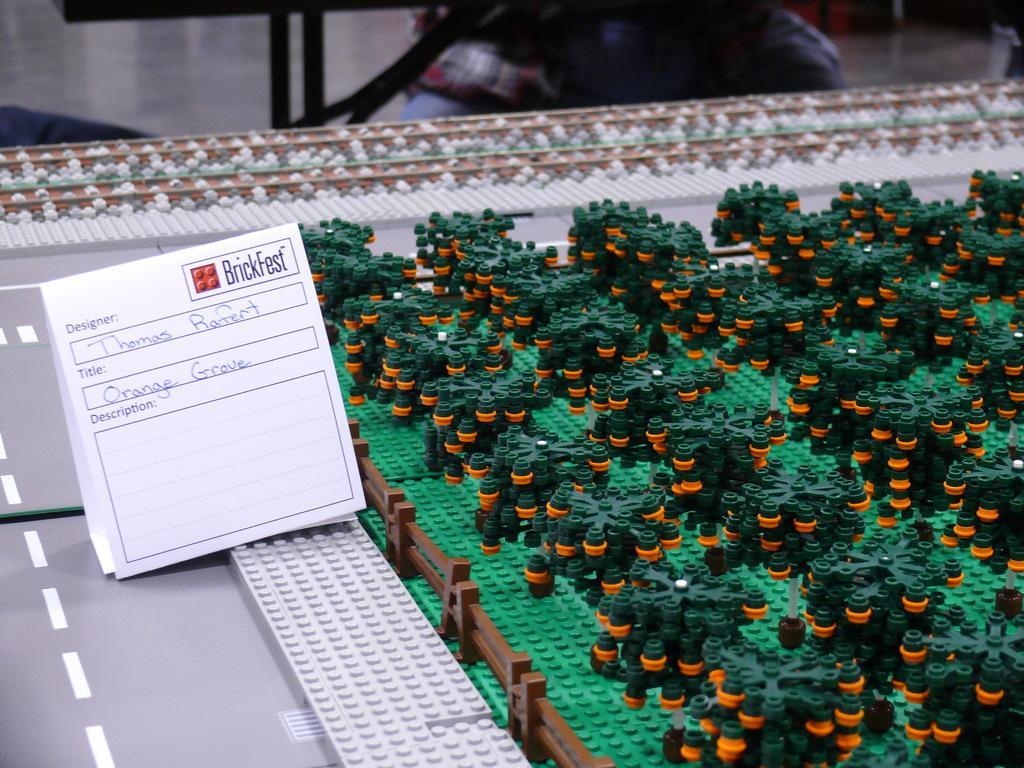In one or two sentences, can you explain what this image depicts? In the picture we can see a table with some puzzle toys which are in the structure of plants and round it we can see a railing and beside it we can see a card on it we can see a designer name as Thomas and title it as orange grove. 